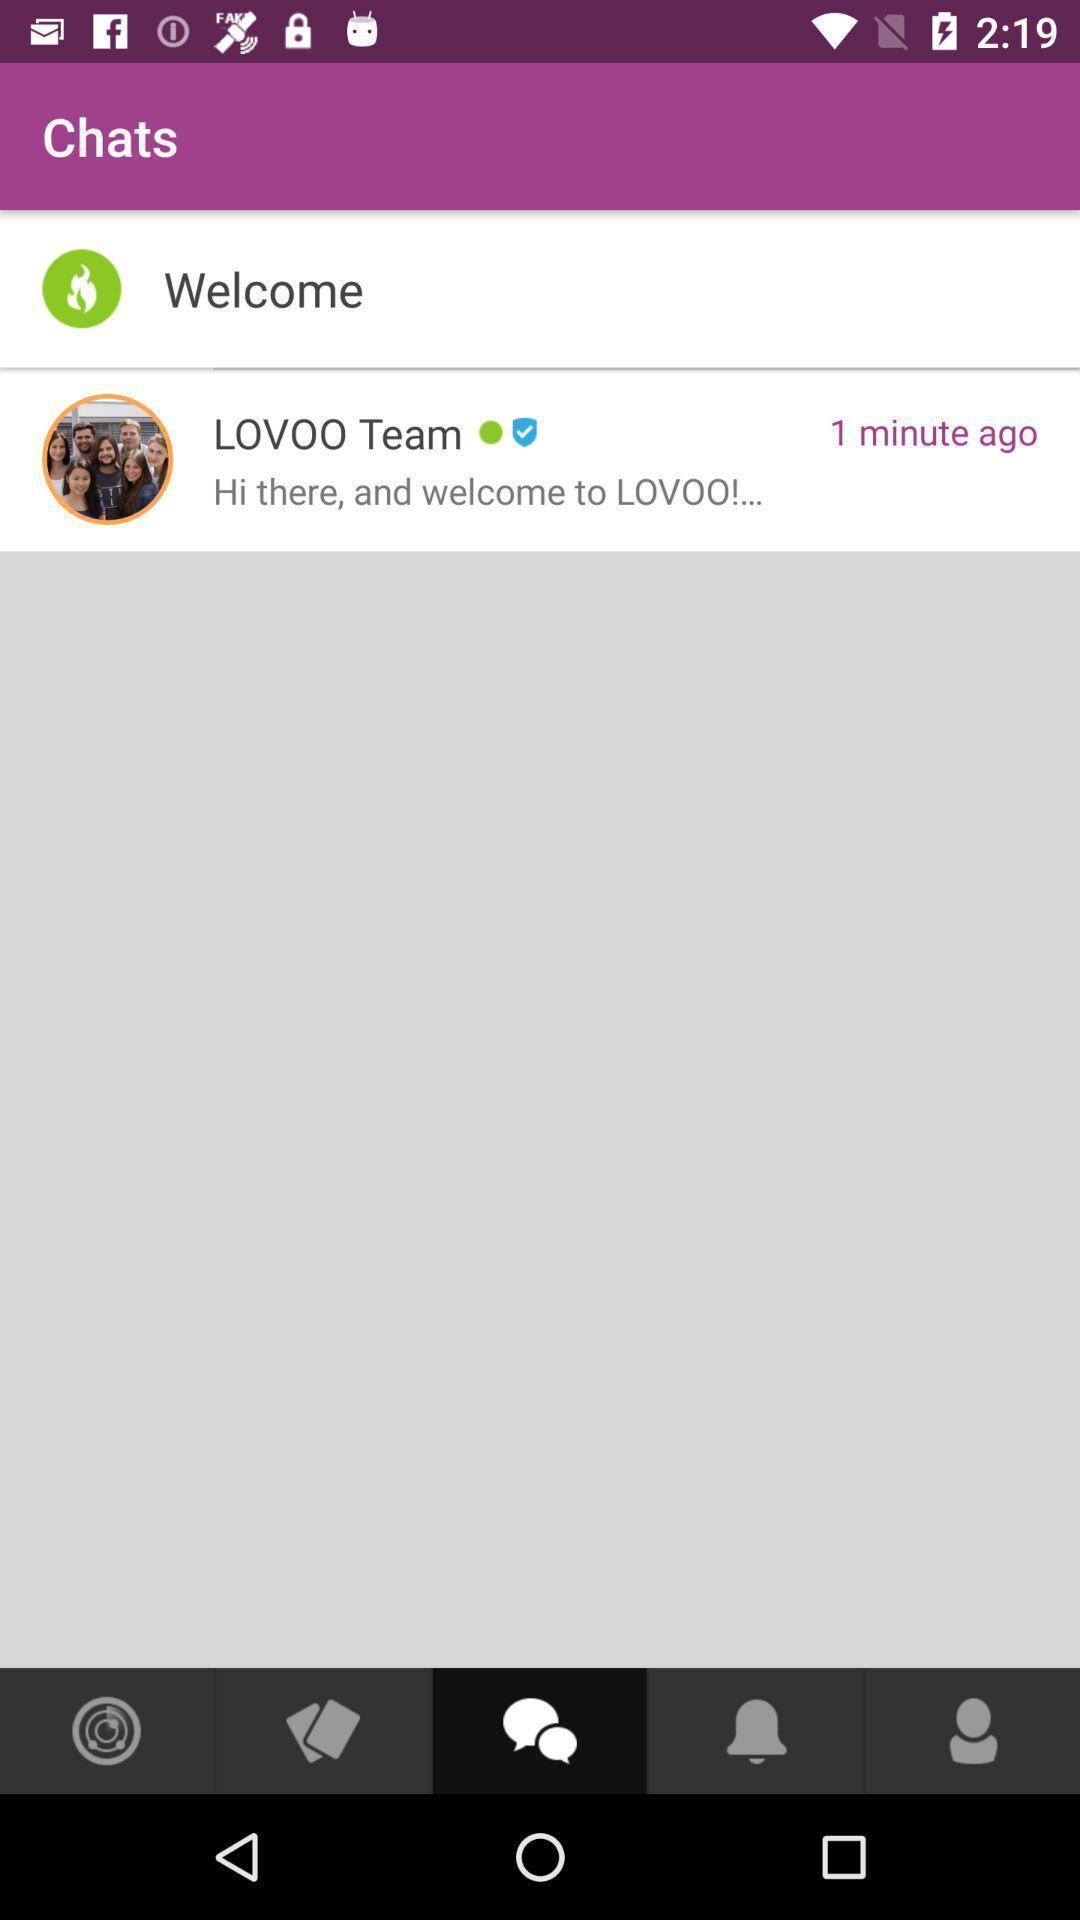Describe the content in this image. Welcoming page. 